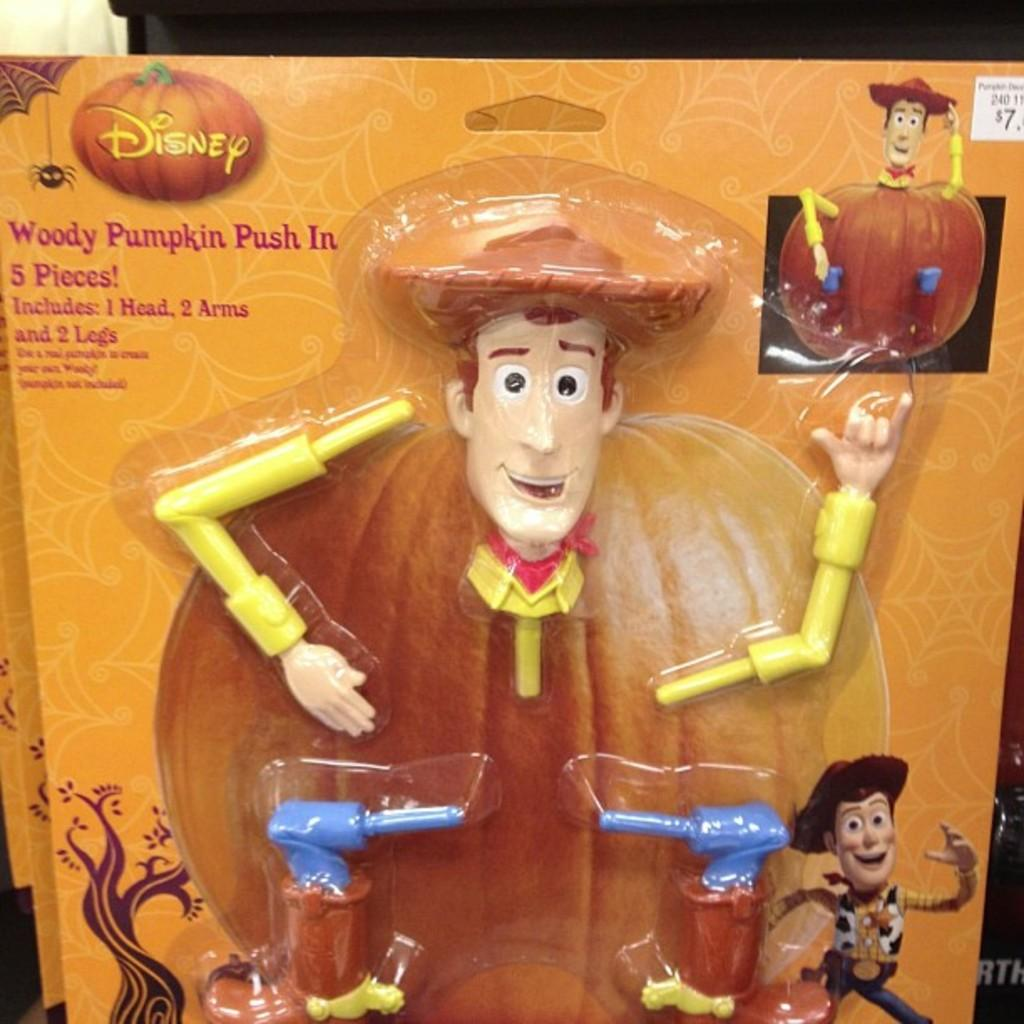What type of visual is the image? The image is a poster. What objects can be seen in the poster? There are toy parts, a tree, and a pumpkin depicted in the poster. Is there any text present in the poster? Yes, there is text present in the poster. What color is the sock hanging on the tree in the poster? There is no sock present in the poster; it only features toy parts, a tree, a pumpkin, and text. 